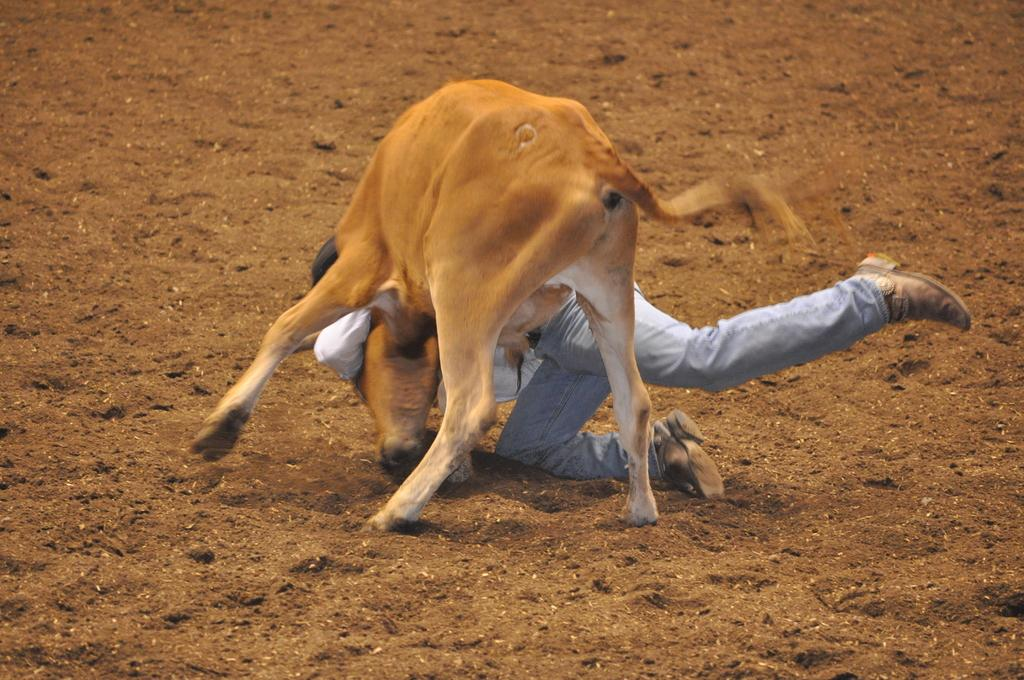What type of animal is present in the image? There is a calf in the image. Are there any human figures in the image? Yes, there is a person in the image. What is the position of the calf and the person in the image? Both the calf and the person are on the ground. Can you tell me where the receipt is located in the image? There is no receipt present in the image. What type of cup is being used by the person in the image? There is no cup visible in the image. 